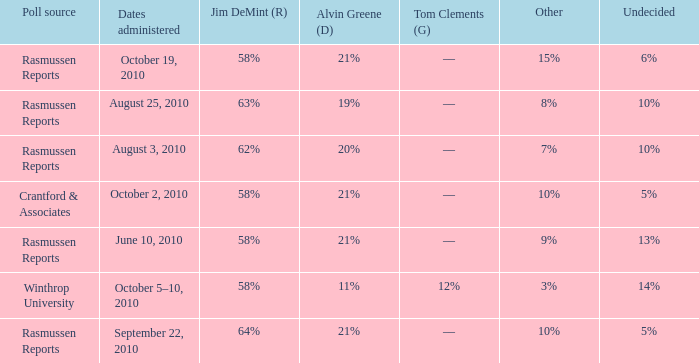What was the vote for Alvin Green when Jim DeMint was 62%? 20%. 